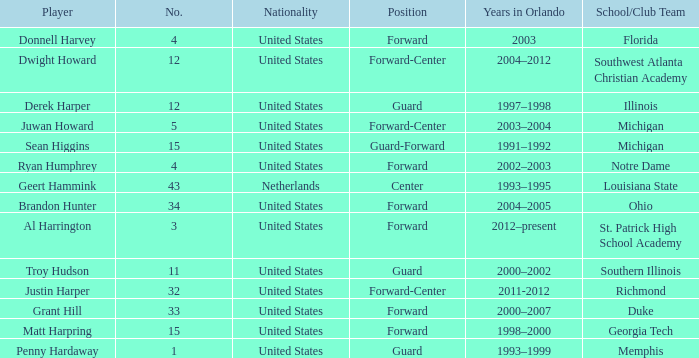What school did Dwight Howard play for Southwest Atlanta Christian Academy. 